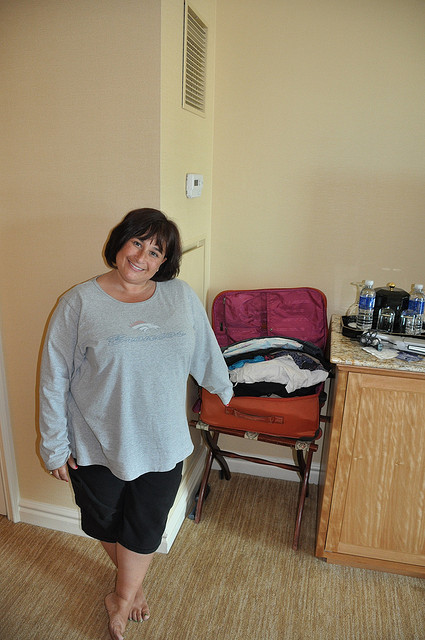<image>What kind of cloth is the poodle standing on? There is no poodle standing on cloth in the image. What pattern is on the rug? There is no rug in the image. However, if there was, potential patterns could be stripes or criss cross. What color is the boy's vest? There is no boy in the image. What kind of cloth is the poodle standing on? I don't know what kind of cloth the poodle is standing on. Please provide me with more information or a clear image. What color is the boy's vest? I am not sure what color is the boy's vest. It is possible that he is not wearing a vest. What pattern is on the rug? I am not sure what pattern is on the rug. 